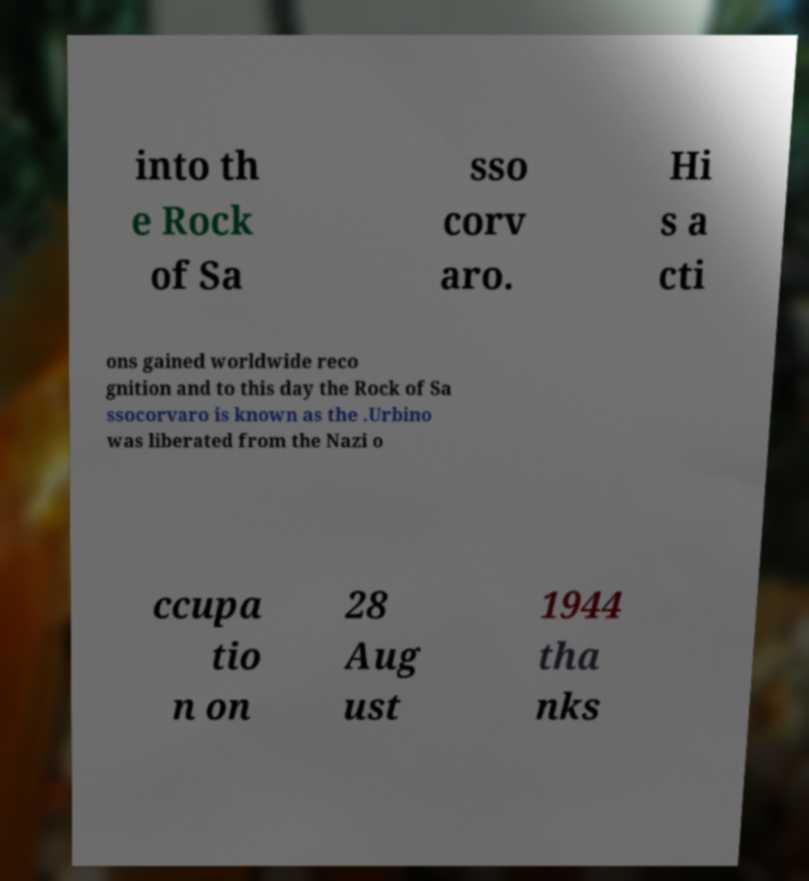Could you assist in decoding the text presented in this image and type it out clearly? into th e Rock of Sa sso corv aro. Hi s a cti ons gained worldwide reco gnition and to this day the Rock of Sa ssocorvaro is known as the .Urbino was liberated from the Nazi o ccupa tio n on 28 Aug ust 1944 tha nks 